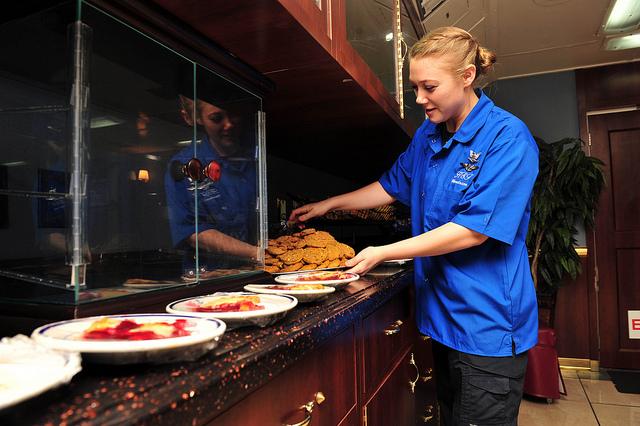Does the lady seem happy?
Keep it brief. Yes. Would you like dessert?
Answer briefly. Yes. What color is the lady's top?
Give a very brief answer. Blue. 